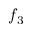<formula> <loc_0><loc_0><loc_500><loc_500>f _ { 3 }</formula> 